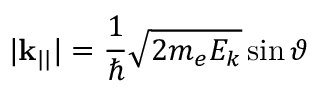Convert formula to latex. <formula><loc_0><loc_0><loc_500><loc_500>| k _ { | | } | = { \frac { 1 } { } } { \sqrt { 2 m _ { e } E _ { k } } } \sin \vartheta</formula> 